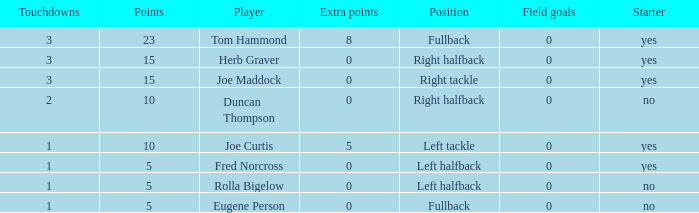What is the average number of field goals scored by a right halfback who had more than 3 touchdowns? None. 